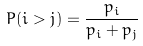Convert formula to latex. <formula><loc_0><loc_0><loc_500><loc_500>P ( i > j ) = \frac { p _ { i } } { p _ { i } + p _ { j } }</formula> 